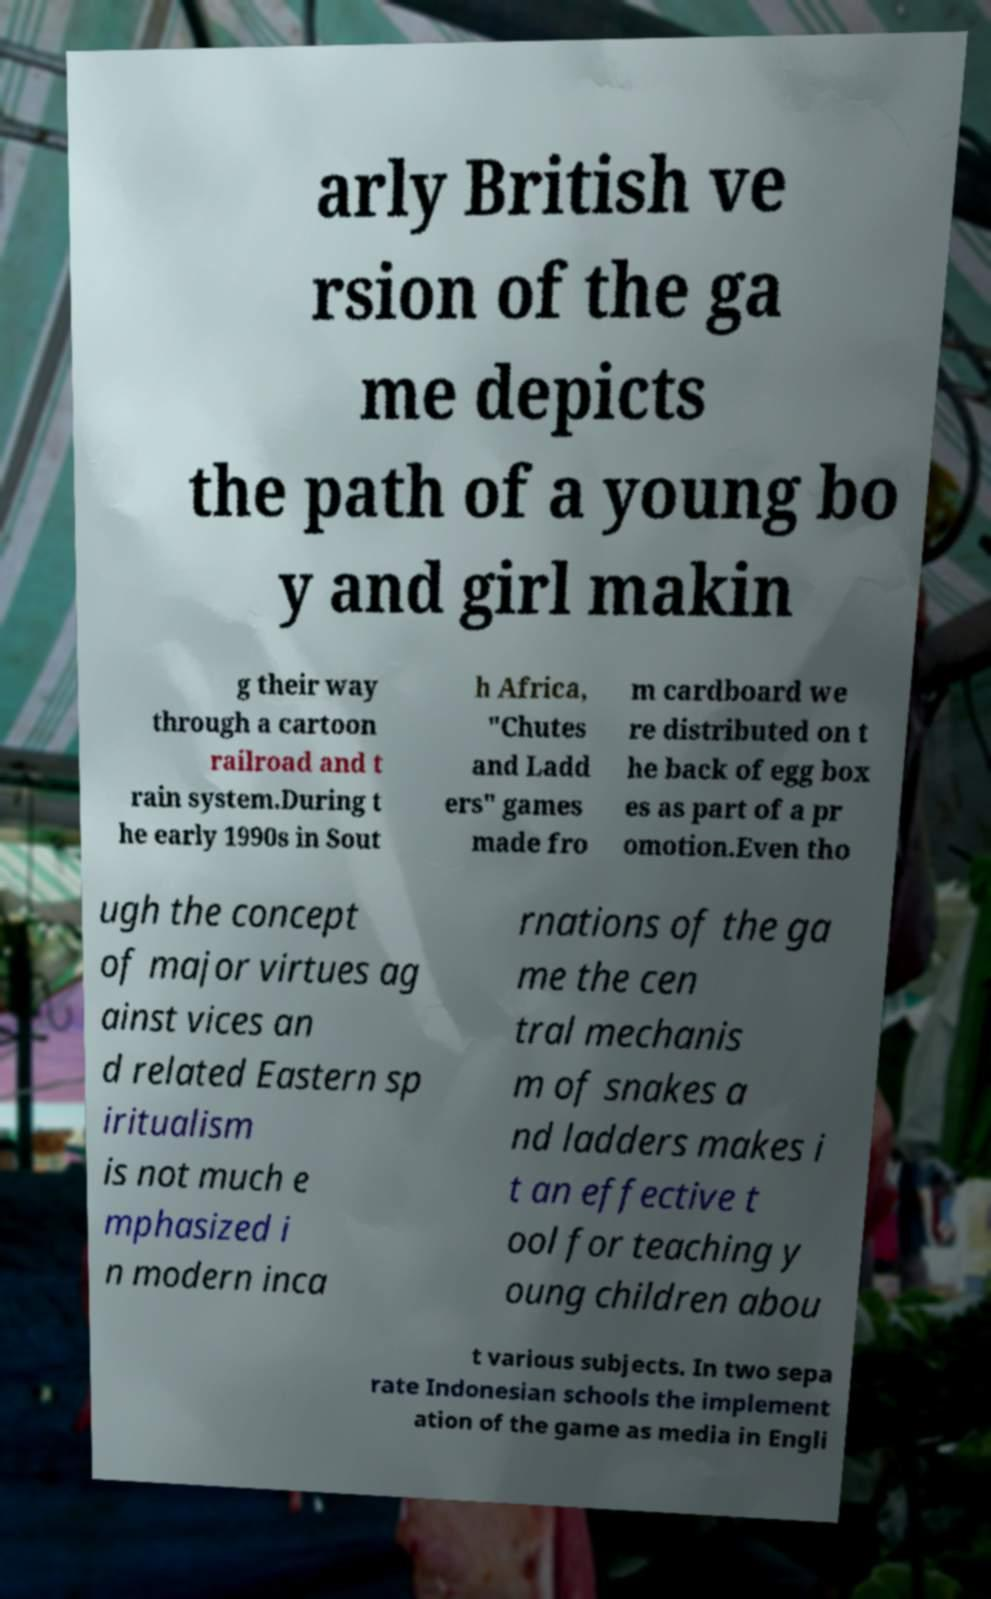What messages or text are displayed in this image? I need them in a readable, typed format. arly British ve rsion of the ga me depicts the path of a young bo y and girl makin g their way through a cartoon railroad and t rain system.During t he early 1990s in Sout h Africa, "Chutes and Ladd ers" games made fro m cardboard we re distributed on t he back of egg box es as part of a pr omotion.Even tho ugh the concept of major virtues ag ainst vices an d related Eastern sp iritualism is not much e mphasized i n modern inca rnations of the ga me the cen tral mechanis m of snakes a nd ladders makes i t an effective t ool for teaching y oung children abou t various subjects. In two sepa rate Indonesian schools the implement ation of the game as media in Engli 